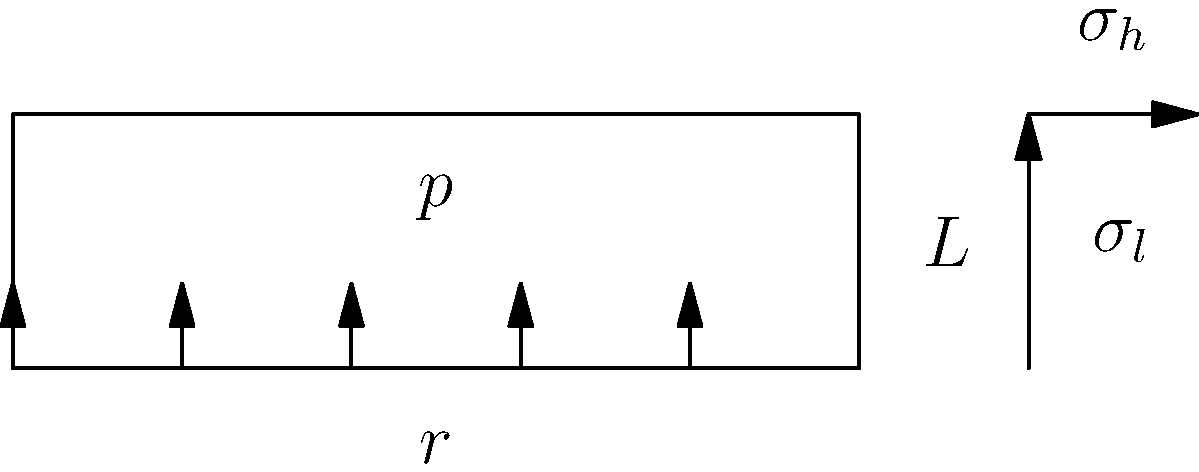In a historic steam locomotive, the boiler's cylindrical shell has an internal radius $r$ of 0.5 m and a length $L$ of 3 m. If the internal pressure $p$ is 1.5 MPa, calculate the hoop stress $\sigma_h$ and longitudinal stress $\sigma_l$ in the shell. Assume the shell thickness is much smaller than the radius. Which stress is greater, and how does this inform your restoration approach? To solve this problem, we'll use the thin-walled pressure vessel formulas:

1. Hoop stress formula: $\sigma_h = \frac{pr}{t}$
2. Longitudinal stress formula: $\sigma_l = \frac{pr}{2t}$

Where:
- $p$ is the internal pressure
- $r$ is the internal radius
- $t$ is the shell thickness

Since we're told the shell thickness is much smaller than the radius, we can use these formulas.

Step 1: Calculate the hoop stress
$\sigma_h = \frac{pr}{t}$

We don't know $t$, but we can see that $\sigma_h$ will be larger than $\sigma_l$ because:
$\sigma_h = \frac{pr}{t}$ and $\sigma_l = \frac{pr}{2t}$

The hoop stress formula has no division by 2 in the numerator, making it twice as large as the longitudinal stress.

Step 2: Calculate the longitudinal stress
$\sigma_l = \frac{pr}{2t} = \frac{1.5 \text{ MPa} \times 0.5 \text{ m}}{2t} = \frac{0.375 \text{ MPa} \cdot \text{m}}{t}$

Step 3: Compare stresses
$\sigma_h = 2\sigma_l$

The hoop stress is twice the longitudinal stress. This means that the circumferential direction of the boiler experiences more stress than the axial direction.

For restoration, this implies:
1. Pay extra attention to circumferential welds and joints.
2. Inspect for potential cracks or fatigue in the circumferential direction more frequently.
3. Consider reinforcing the boiler in the circumferential direction if needed.
4. When pressure testing, be particularly vigilant for leaks or deformations in the circumferential direction.
Answer: Hoop stress ($\sigma_h$) is twice the longitudinal stress ($\sigma_l$). Focus on circumferential integrity during restoration. 